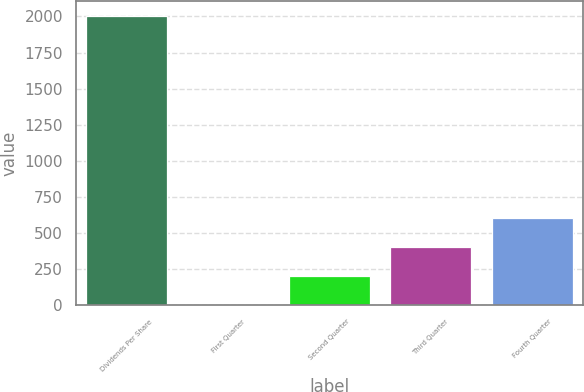Convert chart to OTSL. <chart><loc_0><loc_0><loc_500><loc_500><bar_chart><fcel>Dividends Per Share<fcel>First Quarter<fcel>Second Quarter<fcel>Third Quarter<fcel>Fourth Quarter<nl><fcel>2005<fcel>0.21<fcel>200.69<fcel>401.17<fcel>601.65<nl></chart> 